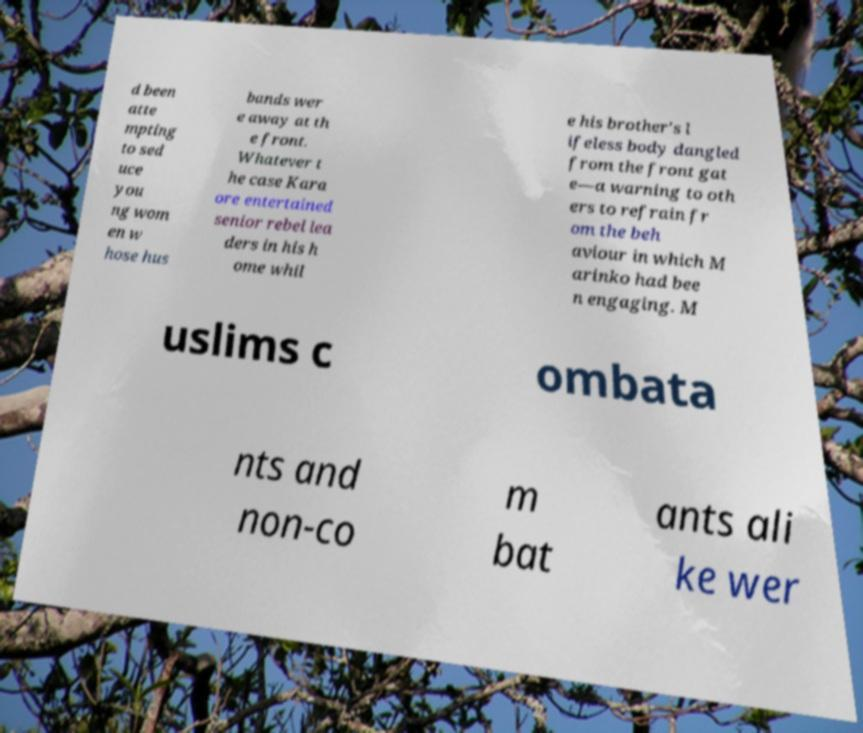For documentation purposes, I need the text within this image transcribed. Could you provide that? d been atte mpting to sed uce you ng wom en w hose hus bands wer e away at th e front. Whatever t he case Kara ore entertained senior rebel lea ders in his h ome whil e his brother's l ifeless body dangled from the front gat e—a warning to oth ers to refrain fr om the beh aviour in which M arinko had bee n engaging. M uslims c ombata nts and non-co m bat ants ali ke wer 